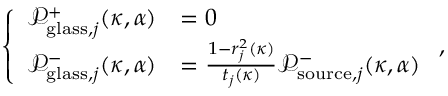<formula> <loc_0><loc_0><loc_500><loc_500>\left \{ \begin{array} { l l } { \mathcal { P } _ { g l a s s , j } ^ { + } ( \kappa , \alpha ) } & { = 0 } \\ { \mathcal { P } _ { g l a s s , j } ^ { - } ( \kappa , \alpha ) } & { = \frac { 1 - r _ { j } ^ { 2 } ( \kappa ) } { t _ { j } ( \kappa ) } \mathcal { P } _ { s o u r c e , j } ^ { - } ( \kappa , \alpha ) } \end{array} ,</formula> 